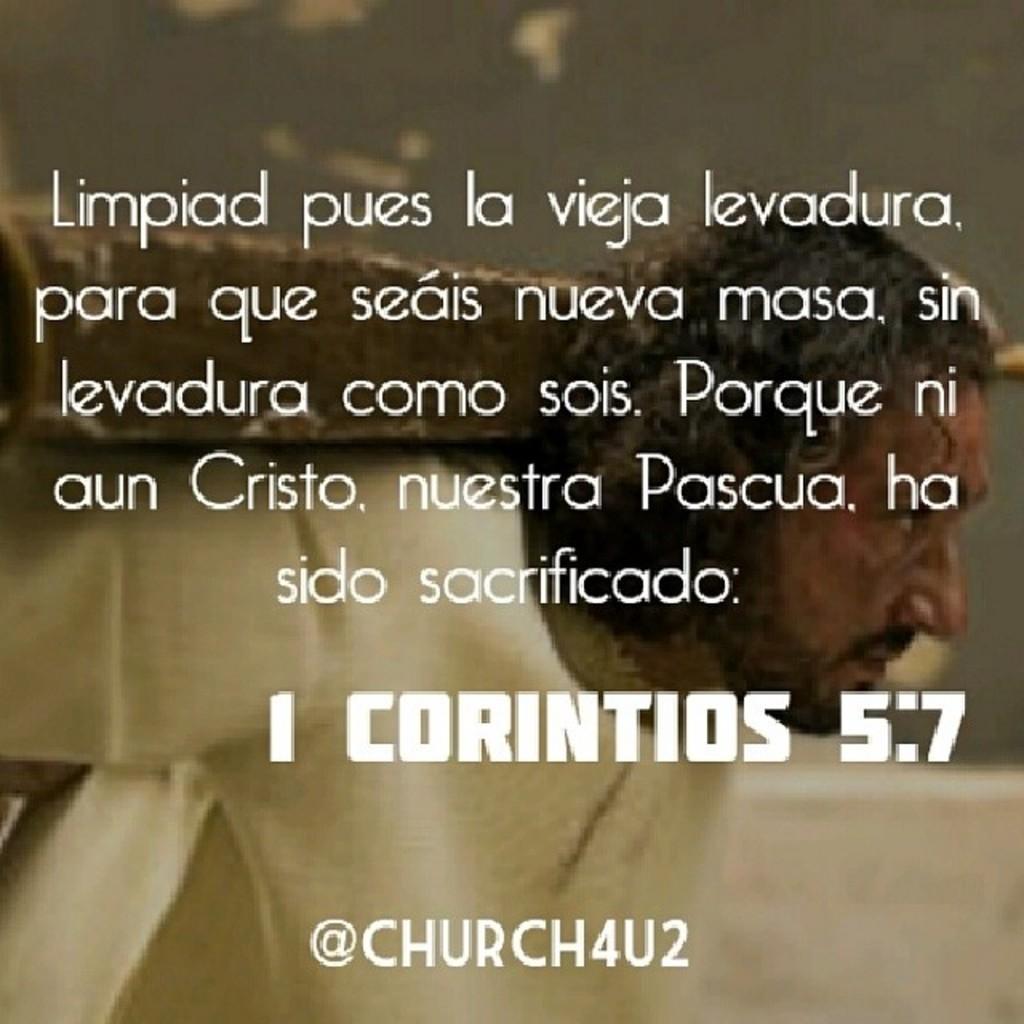Could you give a brief overview of what you see in this image? In this image in the foreground there is some text, and in the background there is one person who is carrying something. 